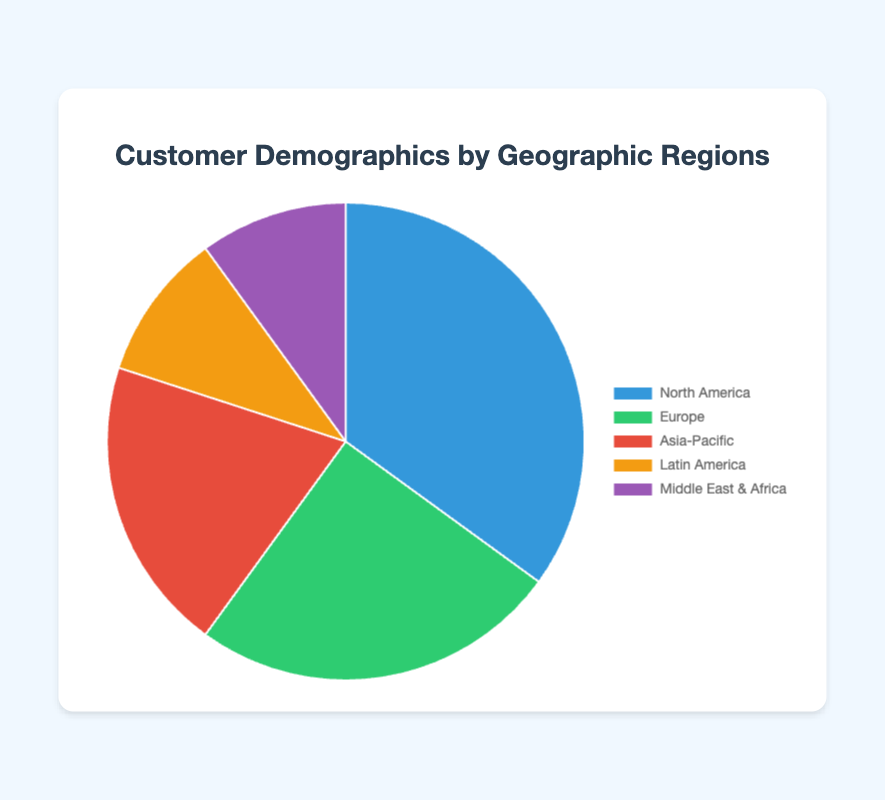What is the percentage of customers in North America? The pie chart shows that the segment representing North America has a label indicating 35 percent.
Answer: 35% Which region has the smallest share of customers? By observing the pie chart, Latin America and Middle East & Africa each have the smallest segment, each labeled with 10 percent.
Answer: Latin America and Middle East & Africa What is the combined percentage of customers from Europe and Asia-Pacific? Add the percentages of Europe (25%) and Asia-Pacific (20%): 25% + 20% = 45%.
Answer: 45% Is the percentage of customers from North America greater than that from Europe? Compare the percentages directly: North America (35%) versus Europe (25%). Since 35% is greater than 25%, the answer is yes.
Answer: Yes How much more significant is the customer base in North America compared to Latin America? Subtract the percentage for Latin America (10%) from North America's percentage (35%): 35% - 10% = 25%.
Answer: 25% What proportion of customers resides outside of North America? Subtract North America's percentage (35%) from 100%: 100% - 35% = 65%.
Answer: 65% Which region has a greater percentage of customers: Middle East & Africa, or Asia-Pacific? Compare the percentages directly: Asia-Pacific (20%) versus Middle East & Africa (10%). Since 20% is greater than 10%, the answer is Asia-Pacific.
Answer: Asia-Pacific If the Europe and Latin America regions were combined, would their percentage exceed that of North America? Add the percentages of Europe (25%) and Latin America (10%): 25% + 10% = 35%. North America’s percentage is also 35%, so they would equal North America's percentage and not exceed it.
Answer: No, they would be equal at 35% Which regions have the same percentage of customers? Both Latin America and Middle East & Africa have segments labeled with 10 percent each.
Answer: Latin America and Middle East & Africa 